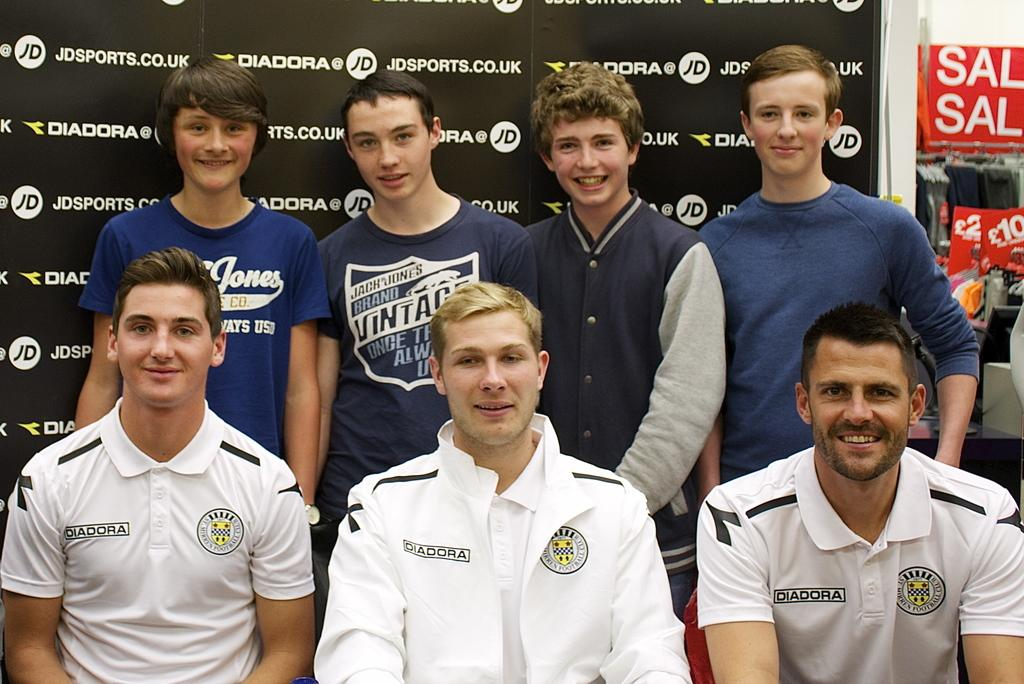<image>
Share a concise interpretation of the image provided. 7 people posing for a picture in front of a JDSPORTS.CO.UK board 